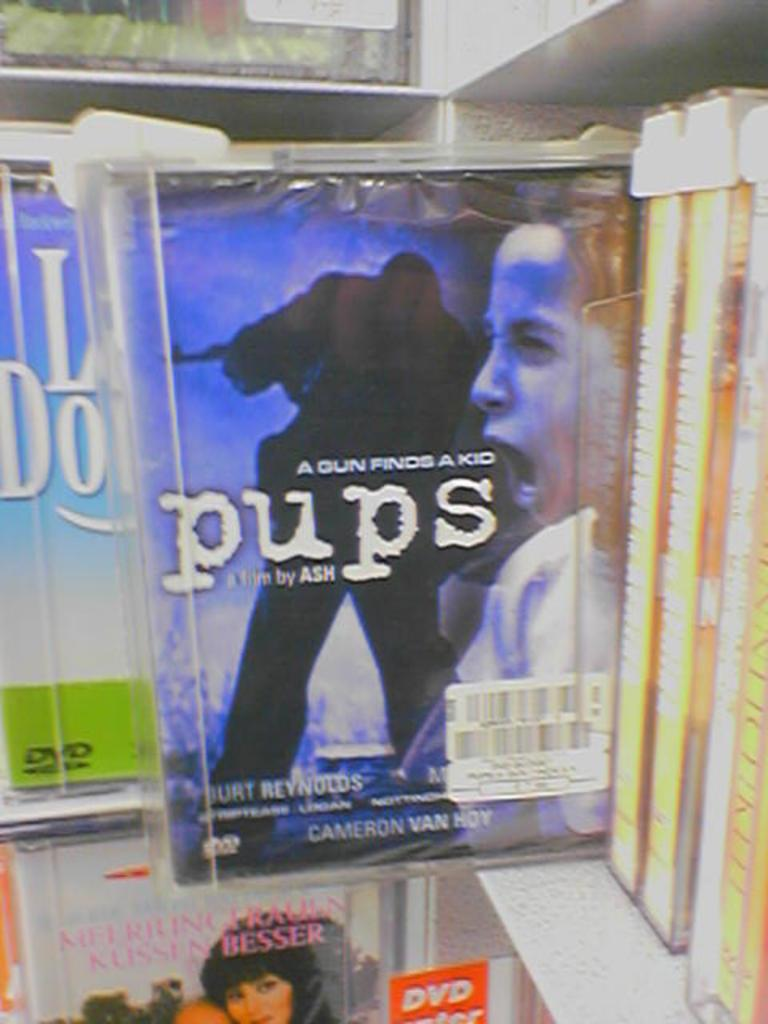<image>
Write a terse but informative summary of the picture. A DVD cover showing a woman yelling with a shadow figure in the background with the name pups in the foreground. 